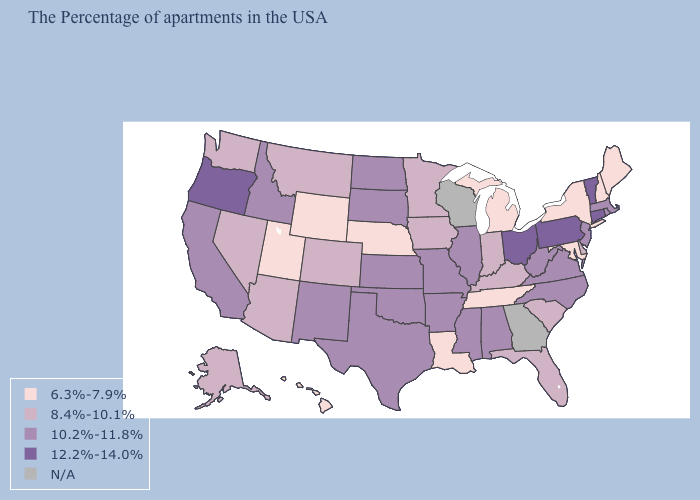Does Pennsylvania have the highest value in the USA?
Answer briefly. Yes. What is the highest value in the USA?
Short answer required. 12.2%-14.0%. What is the value of Idaho?
Quick response, please. 10.2%-11.8%. Name the states that have a value in the range 6.3%-7.9%?
Short answer required. Maine, New Hampshire, New York, Maryland, Michigan, Tennessee, Louisiana, Nebraska, Wyoming, Utah, Hawaii. Name the states that have a value in the range 6.3%-7.9%?
Answer briefly. Maine, New Hampshire, New York, Maryland, Michigan, Tennessee, Louisiana, Nebraska, Wyoming, Utah, Hawaii. What is the lowest value in states that border North Dakota?
Concise answer only. 8.4%-10.1%. Which states hav the highest value in the MidWest?
Write a very short answer. Ohio. What is the value of Ohio?
Quick response, please. 12.2%-14.0%. What is the lowest value in the USA?
Short answer required. 6.3%-7.9%. What is the value of South Carolina?
Be succinct. 8.4%-10.1%. What is the value of Arkansas?
Short answer required. 10.2%-11.8%. Does the map have missing data?
Keep it brief. Yes. Name the states that have a value in the range 6.3%-7.9%?
Give a very brief answer. Maine, New Hampshire, New York, Maryland, Michigan, Tennessee, Louisiana, Nebraska, Wyoming, Utah, Hawaii. Is the legend a continuous bar?
Keep it brief. No. Name the states that have a value in the range N/A?
Write a very short answer. Georgia, Wisconsin. 